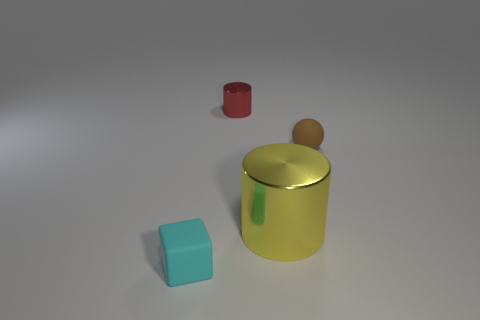Add 3 big yellow cylinders. How many objects exist? 7 Subtract all cubes. How many objects are left? 3 Add 2 large metal things. How many large metal things exist? 3 Subtract 0 yellow balls. How many objects are left? 4 Subtract all blue cylinders. Subtract all tiny red things. How many objects are left? 3 Add 2 cylinders. How many cylinders are left? 4 